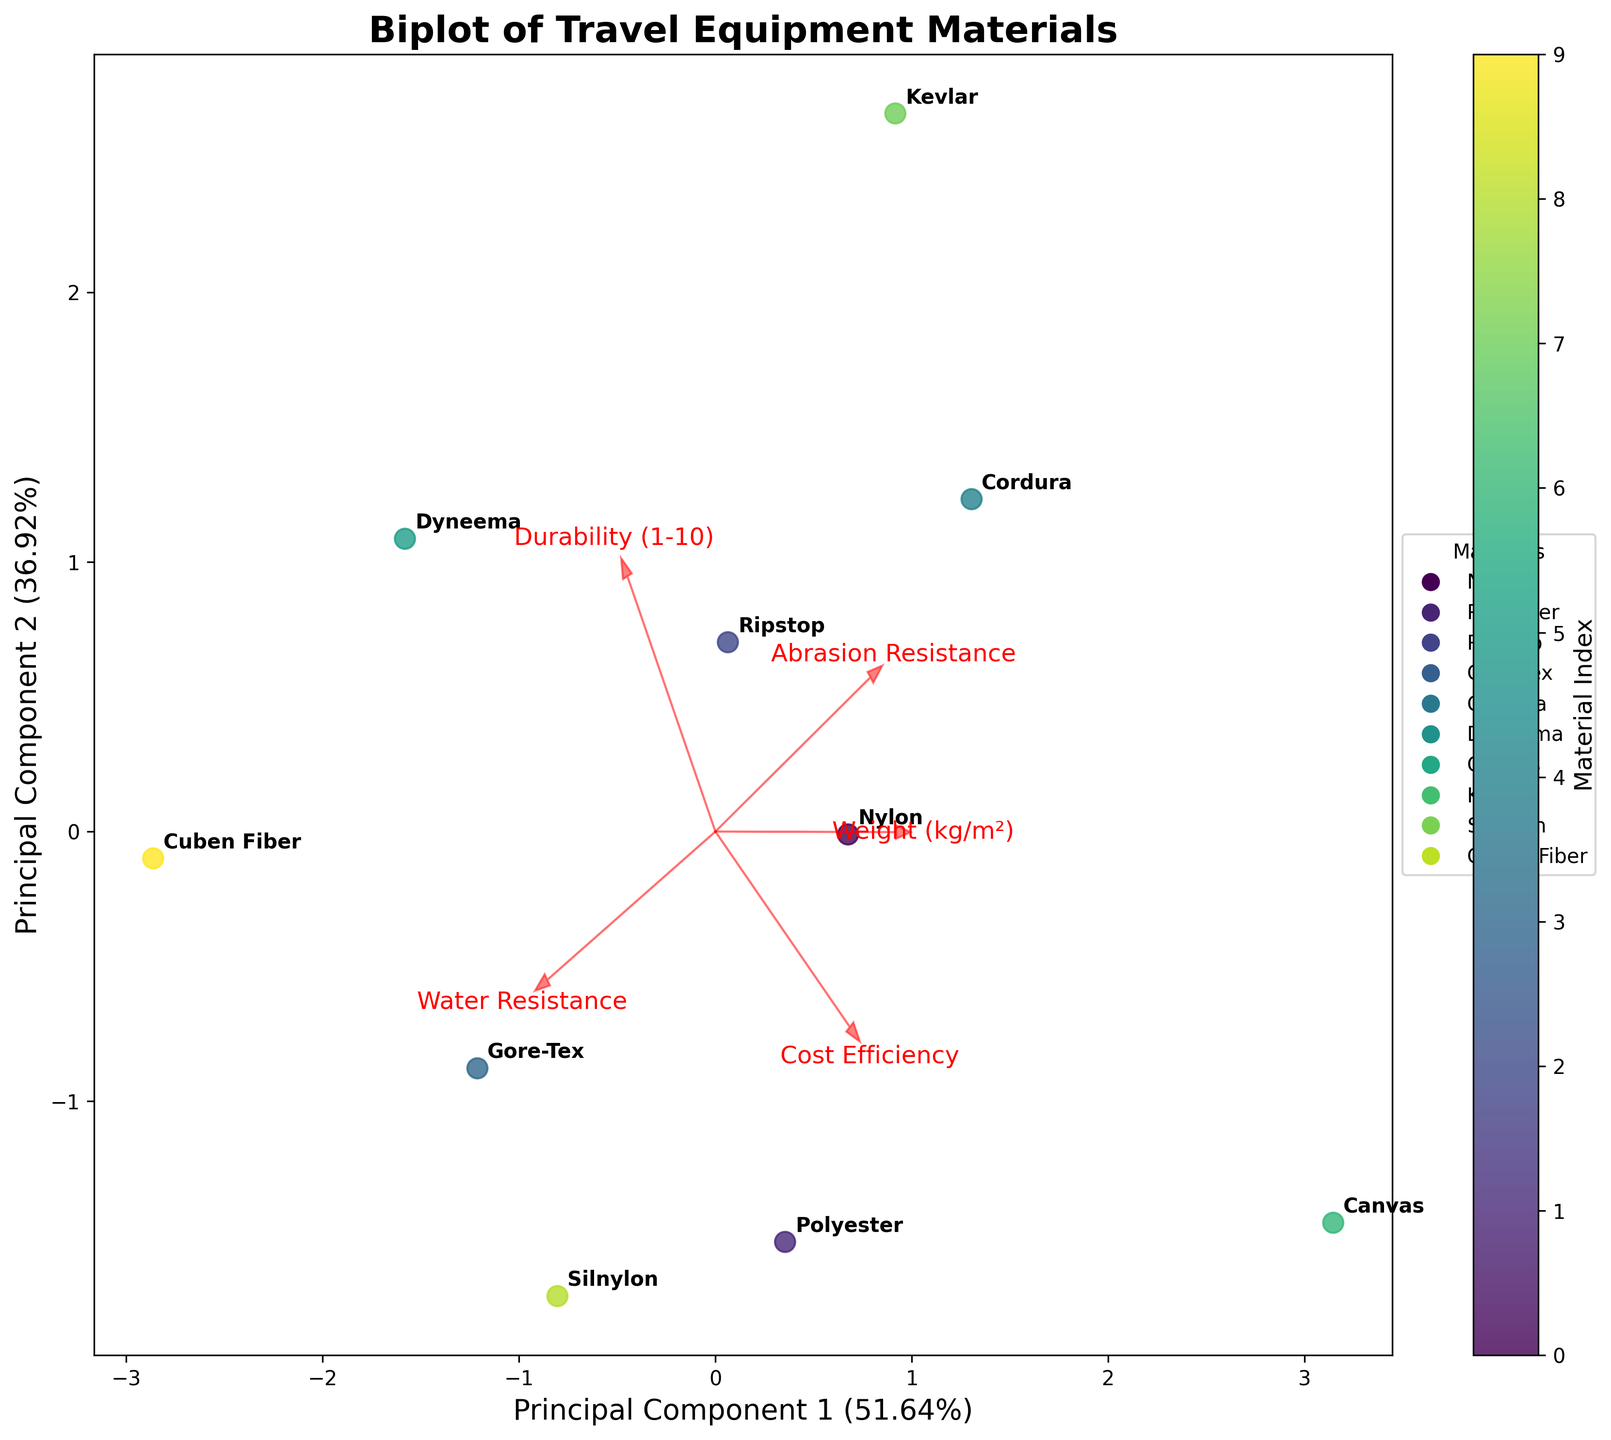How many materials are plotted in the figure? Count the number of different data points labeled by material names.
Answer: 10 Which principal component explains the larger variance? The x-axis shows Principal Component 1, and the y-axis shows Principal Component 2. Check the explained variance percentages on the axes labels.
Answer: Principal Component 1 What material has the highest weight on Principal Component 1? Observe which material's point is farthest to the right on the x-axis, representing Principal Component 1.
Answer: Kevlar How do Silnylon and Ripstop differ in their position on Principal Component 2? Silnylon and Ripstop can be located on the plot. Compare their positions along the y-axis, corresponding to Principal Component 2.
Answer: Silnylon is higher Which feature has the most significant positive loading on Principal Component 1? Look for the arrow extending to the rightmost direction (positive side of PC1) and note the feature it represents.
Answer: Durability (1-10) Which feature shows a strong negative loading on Principal Component 2? Identify the arrow pointing downward (negative side of PC2) and note the corresponding feature.
Answer: Water Resistance Which two materials are closest to each other on the biplot, indicating similar characteristics? Find the pair of materials with the smallest distance between their points on the plot.
Answer: Ripstop and Silnylon Contrast the abrasion resistance of Dyneema and Gore-Tex based on their locations and the corresponding feature's arrow direction. Check the positions of Dyneema and Gore-Tex relative to the arrow representing Abrasion Resistance.
Answer: Dyneema is higher How does the Cost Efficiency loading vector influence the positioning of Cuben Fiber? Observe the direction and length of the Cost Efficiency vector and where Cuben Fiber lies in relation to it.
Answer: Negative influence Which feature's loading vectors suggest it has the strongest influence on differentiating between Canvas and Dyneema? Identify the loading vectors extending furthest along the Principal Component axes where Canvas and Dyneema are most separated.
Answer: Weight (kg/m²) 